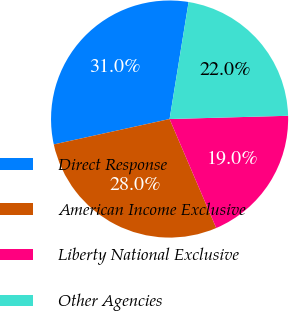Convert chart to OTSL. <chart><loc_0><loc_0><loc_500><loc_500><pie_chart><fcel>Direct Response<fcel>American Income Exclusive<fcel>Liberty National Exclusive<fcel>Other Agencies<nl><fcel>31.0%<fcel>28.0%<fcel>19.0%<fcel>22.0%<nl></chart> 